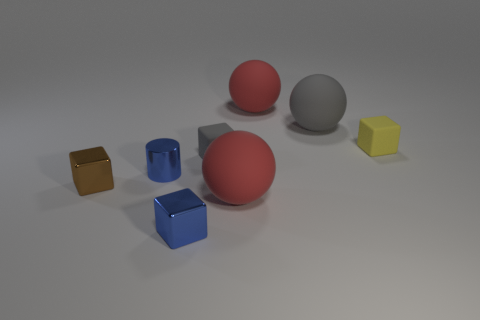Is there any pattern or alignment to how the objects are arranged? The objects are arranged without a precise pattern; they are placed somewhat randomly on a flat surface with varied distances between them. 